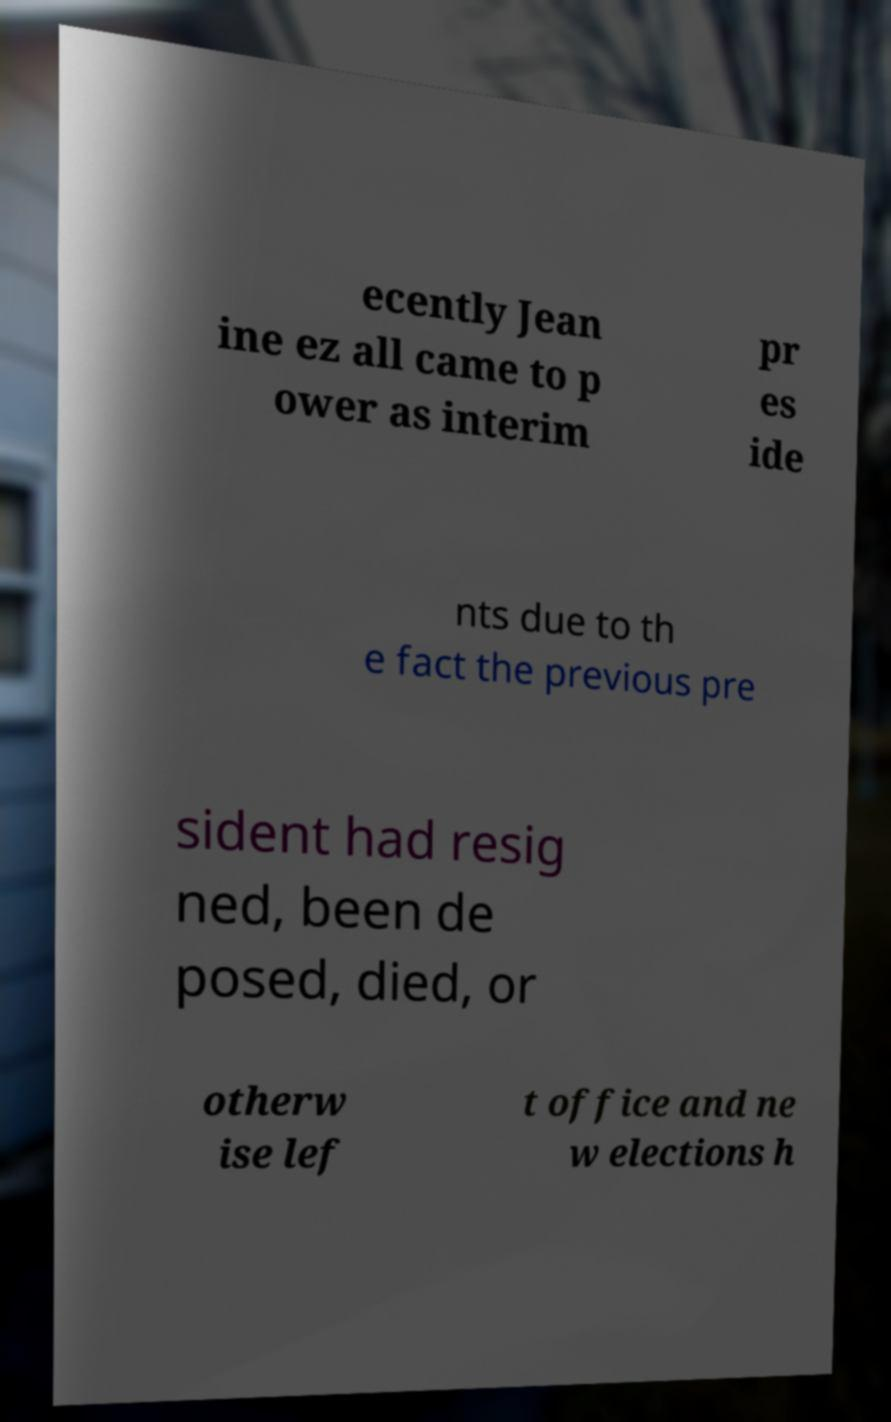Could you extract and type out the text from this image? ecently Jean ine ez all came to p ower as interim pr es ide nts due to th e fact the previous pre sident had resig ned, been de posed, died, or otherw ise lef t office and ne w elections h 